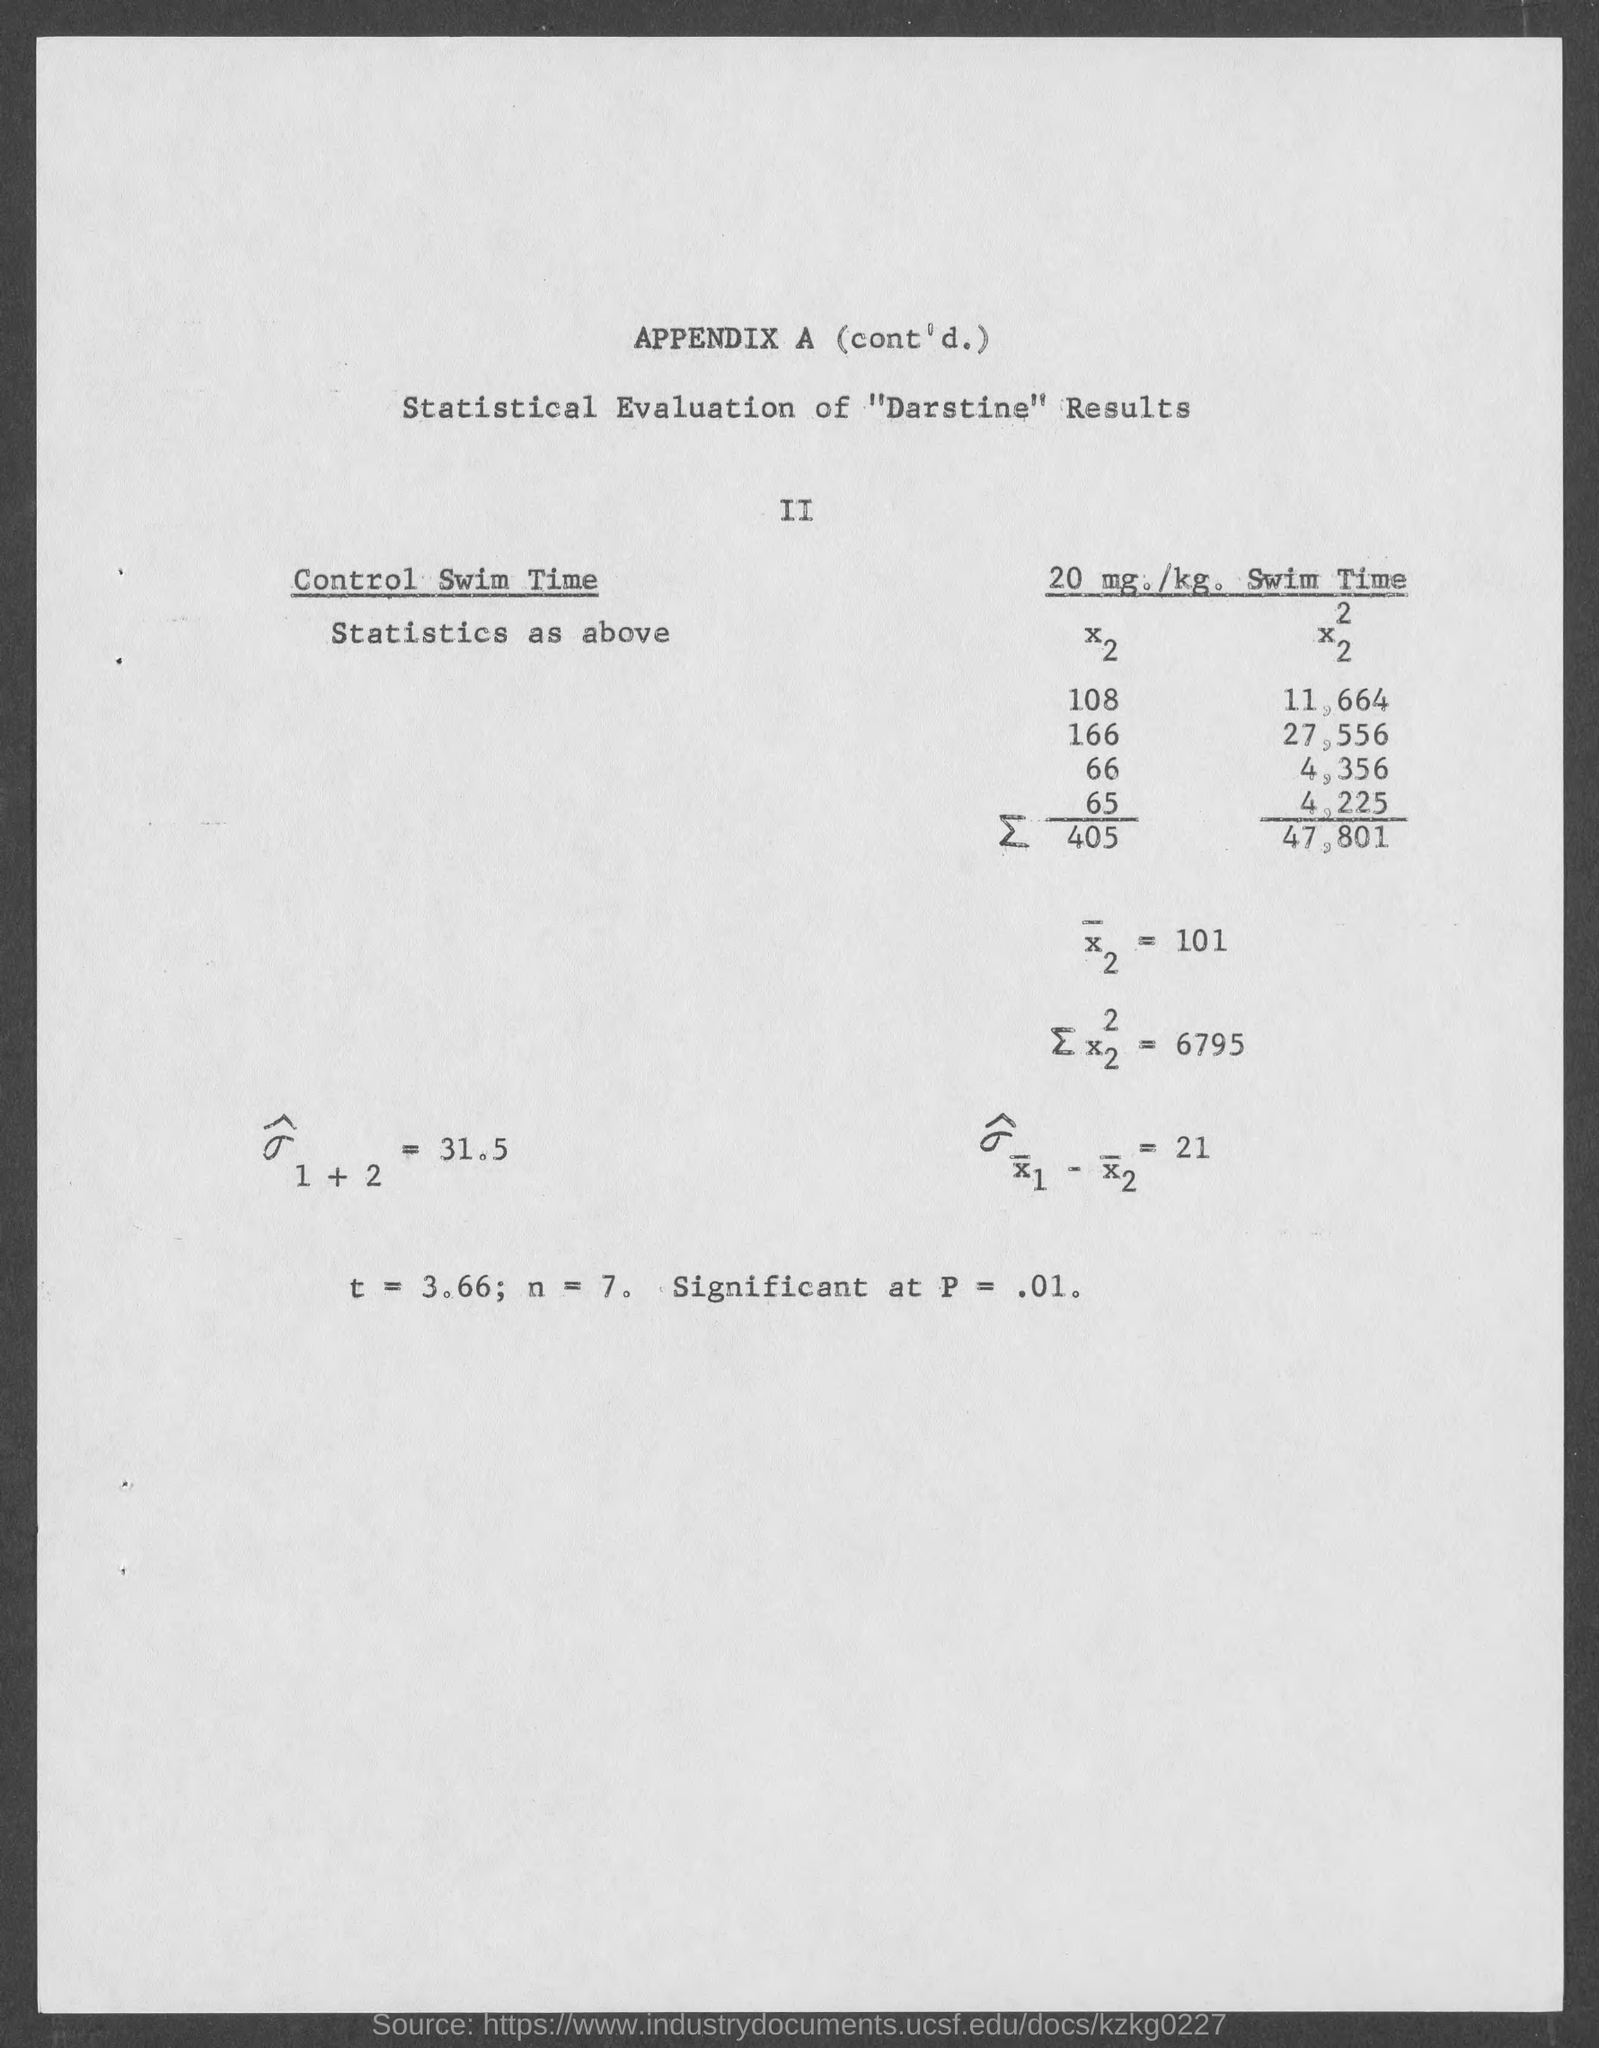What is t= ?
Make the answer very short. 3.66. What is n =?
Your answer should be compact. 7. What is significant at p =?
Your answer should be compact. .01. 